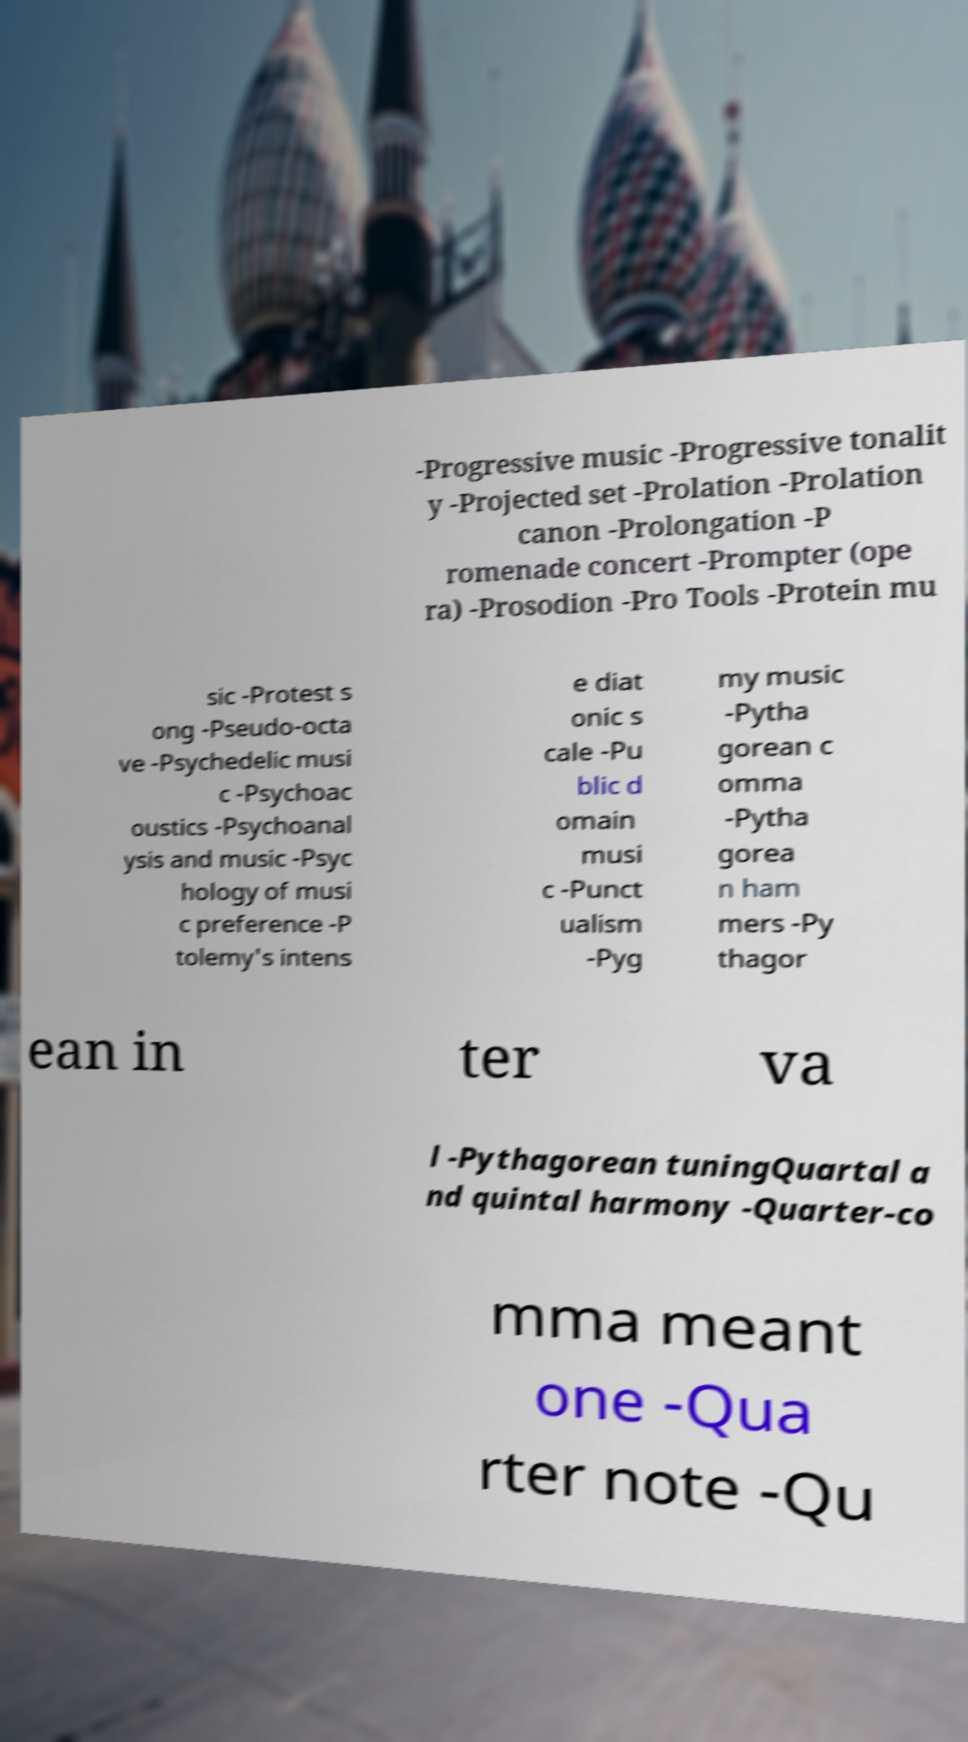Can you read and provide the text displayed in the image?This photo seems to have some interesting text. Can you extract and type it out for me? -Progressive music -Progressive tonalit y -Projected set -Prolation -Prolation canon -Prolongation -P romenade concert -Prompter (ope ra) -Prosodion -Pro Tools -Protein mu sic -Protest s ong -Pseudo-octa ve -Psychedelic musi c -Psychoac oustics -Psychoanal ysis and music -Psyc hology of musi c preference -P tolemy's intens e diat onic s cale -Pu blic d omain musi c -Punct ualism -Pyg my music -Pytha gorean c omma -Pytha gorea n ham mers -Py thagor ean in ter va l -Pythagorean tuningQuartal a nd quintal harmony -Quarter-co mma meant one -Qua rter note -Qu 